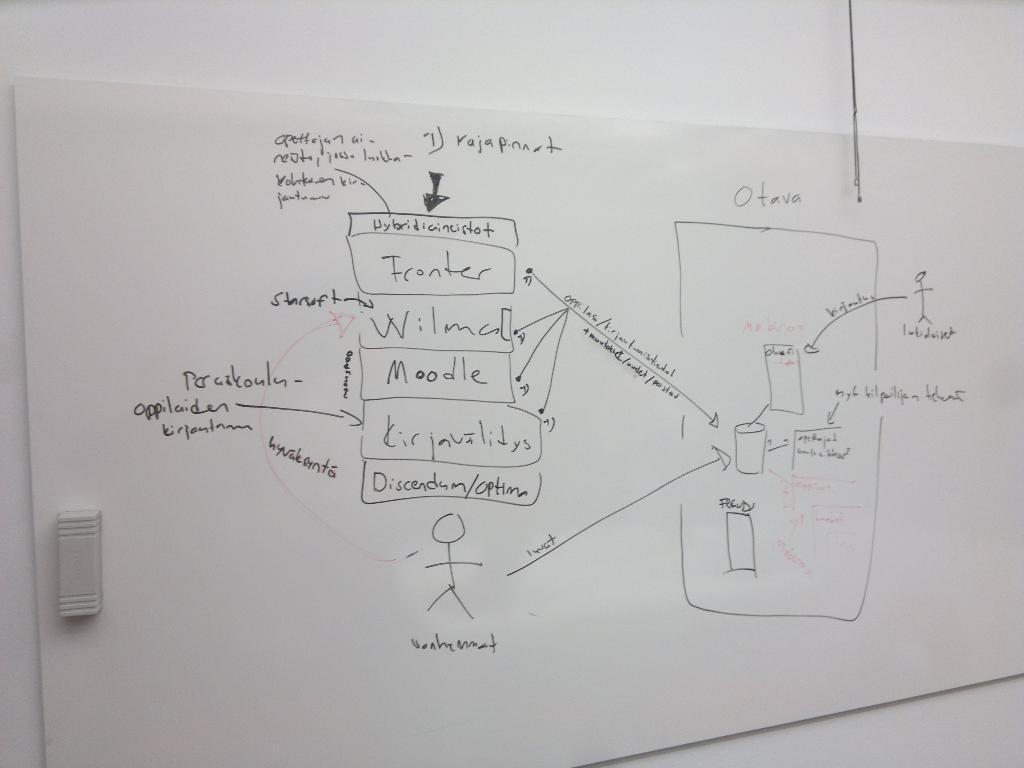What word is written above moodle?
Your answer should be very brief. Wilma. 